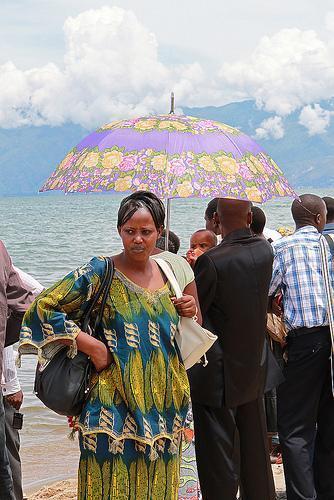How many purses is the woman holding?
Give a very brief answer. 2. How many ears can you see?
Give a very brief answer. 4. How many men are wearing suits?
Give a very brief answer. 1. How many people are wearing dresses?
Give a very brief answer. 2. 